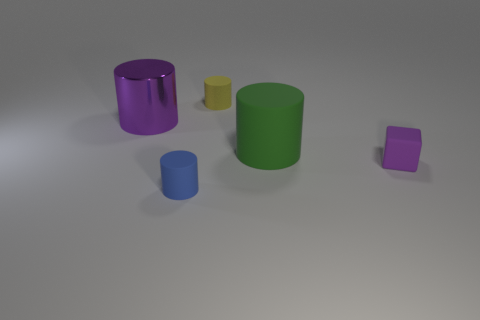Is there anything else that has the same material as the big purple cylinder?
Provide a succinct answer. No. How many other objects are there of the same size as the green rubber object?
Your answer should be compact. 1. Is there anything else that has the same shape as the tiny purple object?
Provide a short and direct response. No. Are there the same number of matte things that are on the right side of the yellow matte cylinder and tiny cylinders?
Your response must be concise. Yes. How many purple blocks are made of the same material as the small yellow cylinder?
Ensure brevity in your answer.  1. There is a large object that is the same material as the cube; what is its color?
Give a very brief answer. Green. Is the shape of the purple metallic thing the same as the yellow matte thing?
Ensure brevity in your answer.  Yes. Is there a purple metal cylinder that is behind the purple object that is on the left side of the matte thing that is behind the big metal cylinder?
Your response must be concise. No. How many cylinders are the same color as the small block?
Keep it short and to the point. 1. What is the shape of the purple metallic thing that is the same size as the green rubber object?
Provide a succinct answer. Cylinder. 